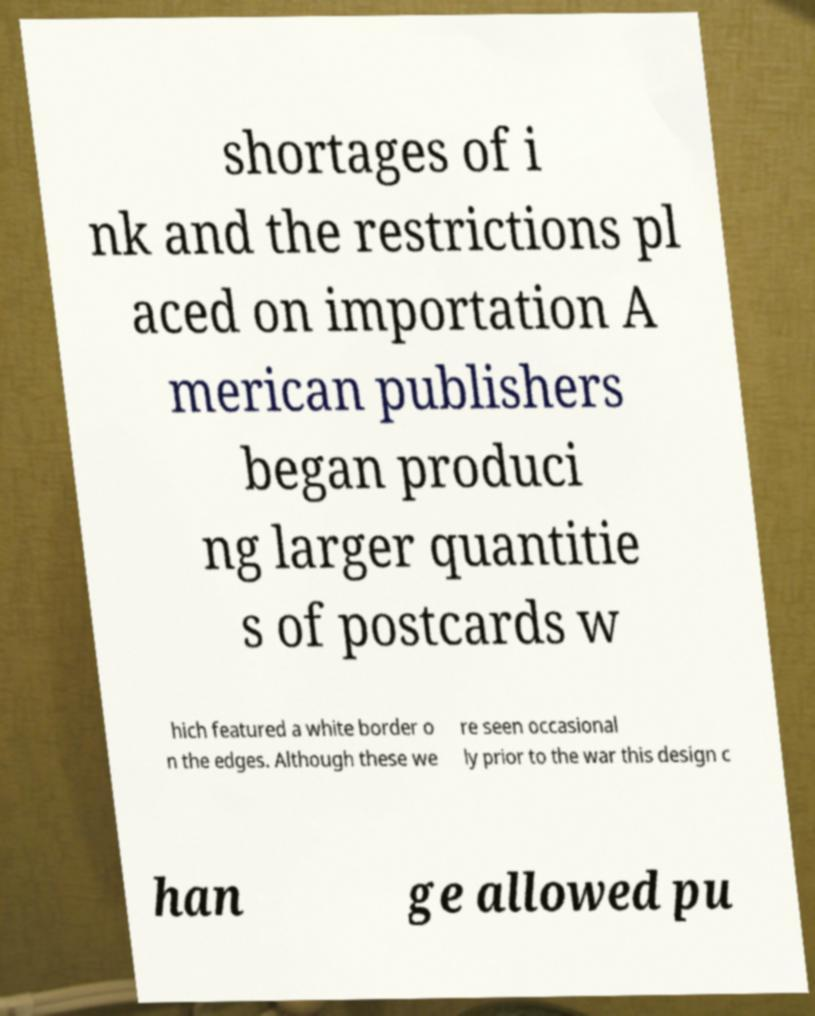Can you read and provide the text displayed in the image?This photo seems to have some interesting text. Can you extract and type it out for me? shortages of i nk and the restrictions pl aced on importation A merican publishers began produci ng larger quantitie s of postcards w hich featured a white border o n the edges. Although these we re seen occasional ly prior to the war this design c han ge allowed pu 